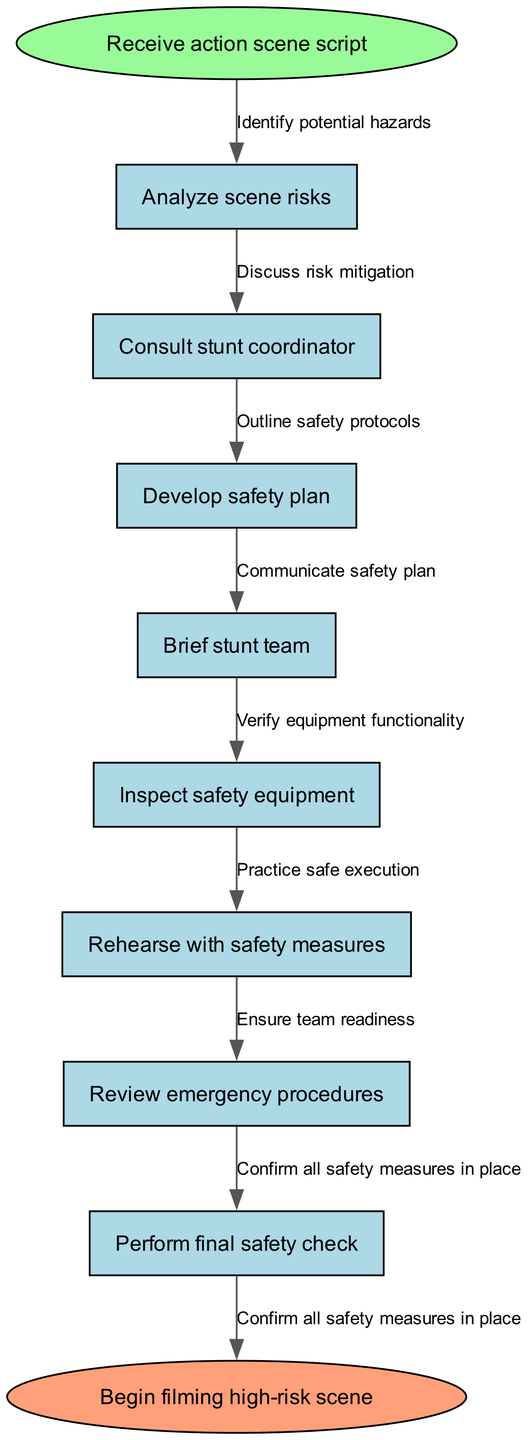What is the first step in the process? The first step in the process is "Receive action scene script," which is shown as the starting node in the flow chart.
Answer: Receive action scene script How many nodes are there in total? The diagram includes a total of 8 nodes: 1 start node, 7 intermediate nodes, and 1 end node.
Answer: 8 What link connects "Analyze scene risks" to the next node? The arrow connecting "Analyze scene risks" to the next node indicates the relationship specified by the edge labeled "Identify potential hazards."
Answer: Identify potential hazards What is the final step before beginning filming? The last node before beginning filming is "Perform final safety check," which is the last intermediate node connected to the end node.
Answer: Perform final safety check Which step comes directly after "Consult stunt coordinator"? The step that comes directly after "Consult stunt coordinator" is "Develop safety plan," as indicated by the flow direction of the edges in the diagram.
Answer: Develop safety plan What is the last action taken in the protocol? The last action taken in the protocol is to "Begin filming high-risk scene," which is represented by the end node of the diagram.
Answer: Begin filming high-risk scene How many safety protocols are outlined in the process? There are a total of 7 safety protocols outlined by the intermediate nodes leading up to the final step in the diagram.
Answer: 7 What does "Rehearse with safety measures" lead to? The action "Rehearse with safety measures" leads to "Review emergency procedures," as it follows sequentially in the flow of the diagram.
Answer: Review emergency procedures What action is taken before "Inspect safety equipment"? The action taken before "Inspect safety equipment" is "Brief stunt team," which directly precedes it in the sequence of steps.
Answer: Brief stunt team 